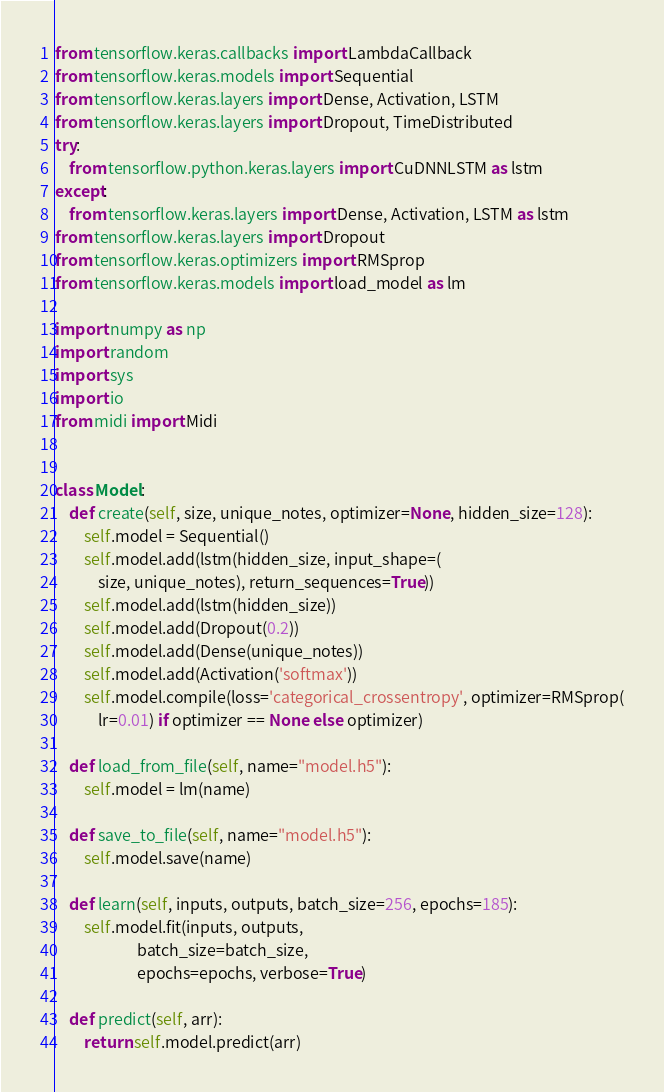<code> <loc_0><loc_0><loc_500><loc_500><_Python_>from tensorflow.keras.callbacks import LambdaCallback
from tensorflow.keras.models import Sequential
from tensorflow.keras.layers import Dense, Activation, LSTM
from tensorflow.keras.layers import Dropout, TimeDistributed
try:
    from tensorflow.python.keras.layers import CuDNNLSTM as lstm
except:
    from tensorflow.keras.layers import Dense, Activation, LSTM as lstm
from tensorflow.keras.layers import Dropout
from tensorflow.keras.optimizers import RMSprop
from tensorflow.keras.models import load_model as lm

import numpy as np
import random
import sys
import io
from midi import Midi


class Model:
    def create(self, size, unique_notes, optimizer=None, hidden_size=128):
        self.model = Sequential()
        self.model.add(lstm(hidden_size, input_shape=(
            size, unique_notes), return_sequences=True))
        self.model.add(lstm(hidden_size))
        self.model.add(Dropout(0.2))
        self.model.add(Dense(unique_notes))
        self.model.add(Activation('softmax'))
        self.model.compile(loss='categorical_crossentropy', optimizer=RMSprop(
            lr=0.01) if optimizer == None else optimizer)

    def load_from_file(self, name="model.h5"):
        self.model = lm(name)

    def save_to_file(self, name="model.h5"):
        self.model.save(name)

    def learn(self, inputs, outputs, batch_size=256, epochs=185):
        self.model.fit(inputs, outputs,
                       batch_size=batch_size,
                       epochs=epochs, verbose=True)

    def predict(self, arr):
        return self.model.predict(arr)
</code> 